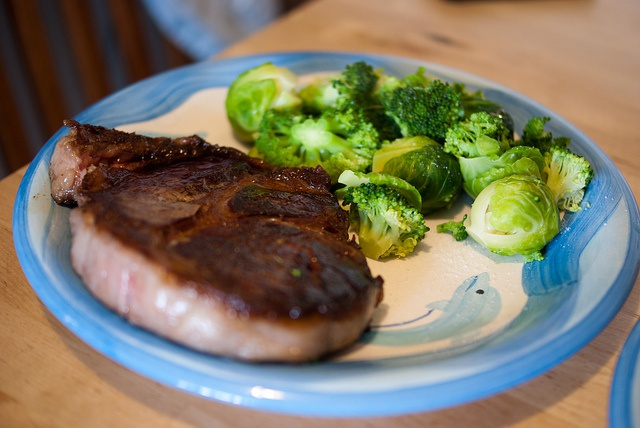Describe the objects in this image and their specific colors. I can see dining table in black, tan, darkgray, and maroon tones, broccoli in black, olive, darkgreen, and lightgreen tones, broccoli in black, darkgreen, and olive tones, broccoli in black and olive tones, and broccoli in black, olive, lightgreen, and darkgreen tones in this image. 